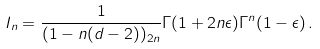<formula> <loc_0><loc_0><loc_500><loc_500>I _ { n } = \frac { 1 } { ( 1 - n ( d - 2 ) ) _ { 2 n } } \Gamma ( 1 + 2 n \epsilon ) \Gamma ^ { n } ( 1 - \epsilon ) \, .</formula> 